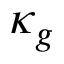<formula> <loc_0><loc_0><loc_500><loc_500>\kappa _ { g }</formula> 